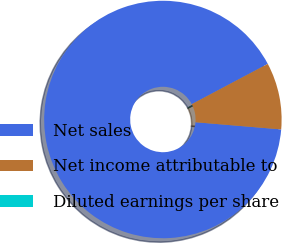Convert chart to OTSL. <chart><loc_0><loc_0><loc_500><loc_500><pie_chart><fcel>Net sales<fcel>Net income attributable to<fcel>Diluted earnings per share<nl><fcel>90.91%<fcel>9.09%<fcel>0.0%<nl></chart> 